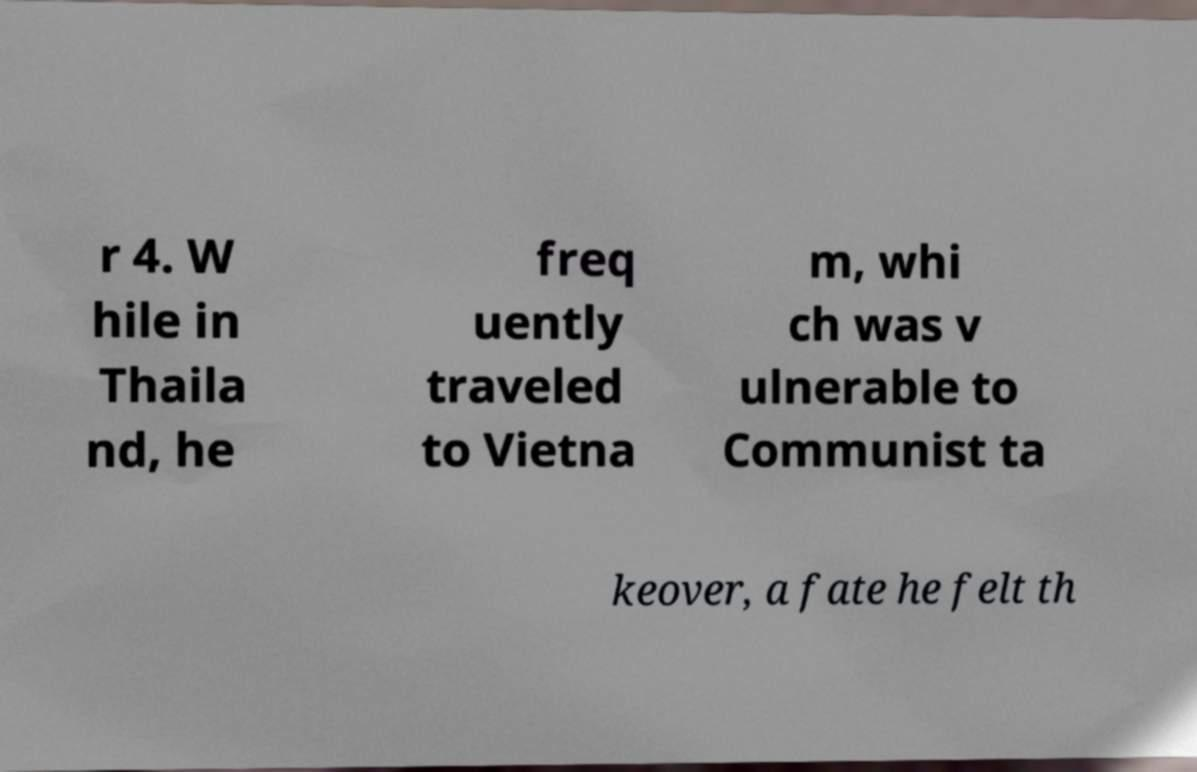I need the written content from this picture converted into text. Can you do that? r 4. W hile in Thaila nd, he freq uently traveled to Vietna m, whi ch was v ulnerable to Communist ta keover, a fate he felt th 